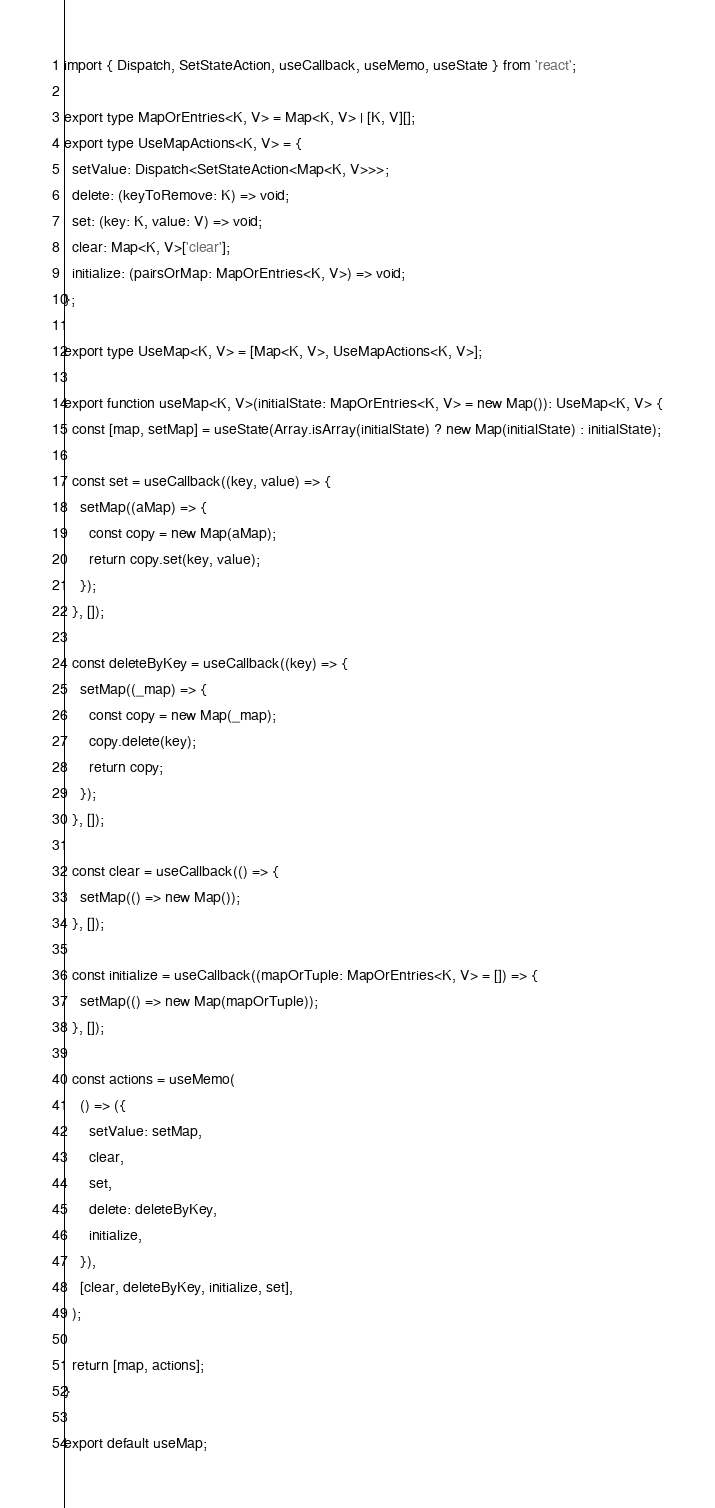<code> <loc_0><loc_0><loc_500><loc_500><_TypeScript_>import { Dispatch, SetStateAction, useCallback, useMemo, useState } from 'react';

export type MapOrEntries<K, V> = Map<K, V> | [K, V][];
export type UseMapActions<K, V> = {
  setValue: Dispatch<SetStateAction<Map<K, V>>>;
  delete: (keyToRemove: K) => void;
  set: (key: K, value: V) => void;
  clear: Map<K, V>['clear'];
  initialize: (pairsOrMap: MapOrEntries<K, V>) => void;
};

export type UseMap<K, V> = [Map<K, V>, UseMapActions<K, V>];

export function useMap<K, V>(initialState: MapOrEntries<K, V> = new Map()): UseMap<K, V> {
  const [map, setMap] = useState(Array.isArray(initialState) ? new Map(initialState) : initialState);

  const set = useCallback((key, value) => {
    setMap((aMap) => {
      const copy = new Map(aMap);
      return copy.set(key, value);
    });
  }, []);

  const deleteByKey = useCallback((key) => {
    setMap((_map) => {
      const copy = new Map(_map);
      copy.delete(key);
      return copy;
    });
  }, []);

  const clear = useCallback(() => {
    setMap(() => new Map());
  }, []);

  const initialize = useCallback((mapOrTuple: MapOrEntries<K, V> = []) => {
    setMap(() => new Map(mapOrTuple));
  }, []);

  const actions = useMemo(
    () => ({
      setValue: setMap,
      clear,
      set,
      delete: deleteByKey,
      initialize,
    }),
    [clear, deleteByKey, initialize, set],
  );

  return [map, actions];
}

export default useMap;
</code> 